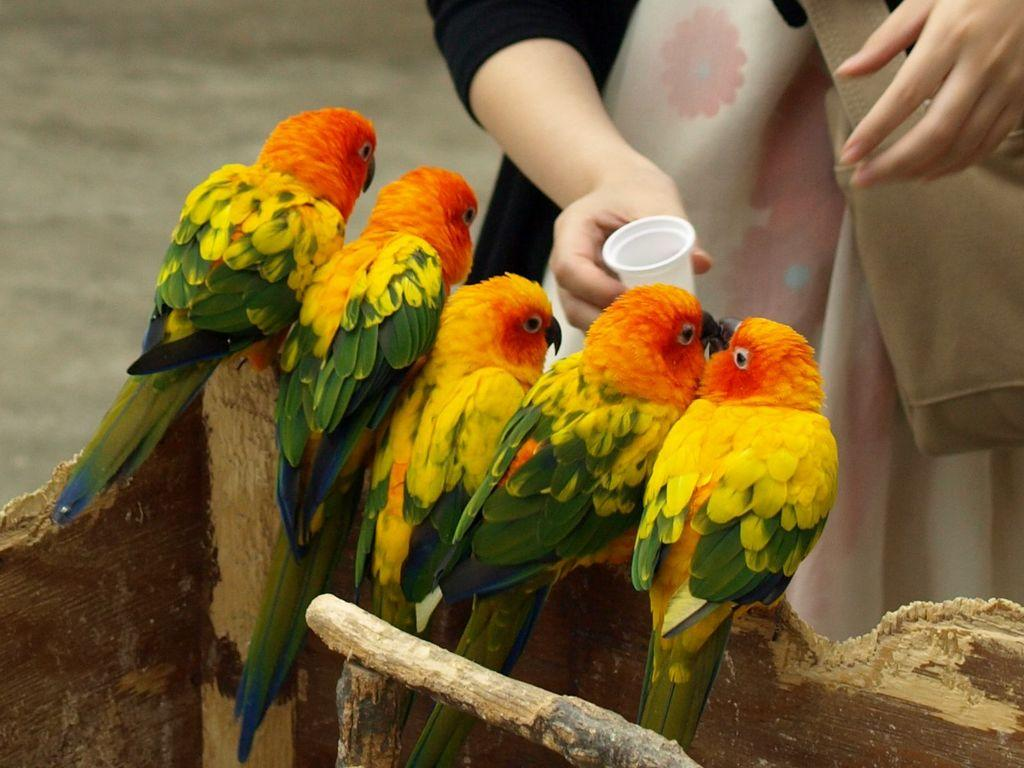What is located in the foreground of the picture? There are birds in the foreground of the picture. What are the birds perched on? The birds are on a wooden object. Can you describe the person in the image? There is a person at the top of the image, and they are holding a cup. What type of pies can be seen in the image? There are no pies present in the image. What causes the spark to occur in the image? There is no spark present in the image. 